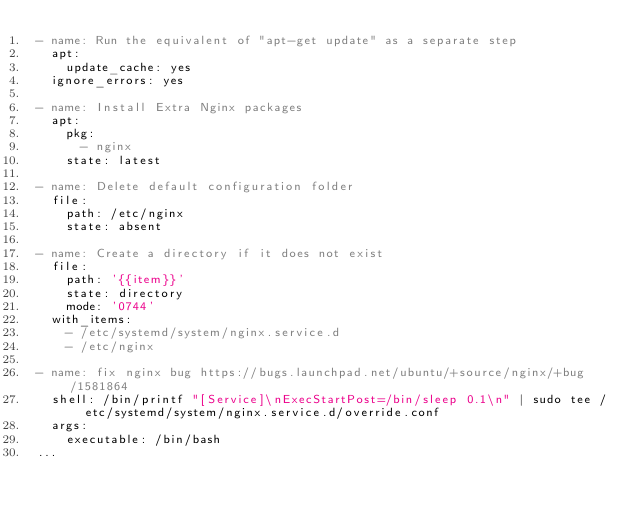Convert code to text. <code><loc_0><loc_0><loc_500><loc_500><_YAML_>- name: Run the equivalent of "apt-get update" as a separate step
  apt:
    update_cache: yes
  ignore_errors: yes

- name: Install Extra Nginx packages
  apt:
    pkg:
      - nginx
    state: latest

- name: Delete default configuration folder
  file:
    path: /etc/nginx
    state: absent

- name: Create a directory if it does not exist
  file:
    path: '{{item}}'
    state: directory
    mode: '0744'
  with_items:
    - /etc/systemd/system/nginx.service.d
    - /etc/nginx

- name: fix nginx bug https://bugs.launchpad.net/ubuntu/+source/nginx/+bug/1581864
  shell: /bin/printf "[Service]\nExecStartPost=/bin/sleep 0.1\n" | sudo tee /etc/systemd/system/nginx.service.d/override.conf
  args:
    executable: /bin/bash
...
</code> 